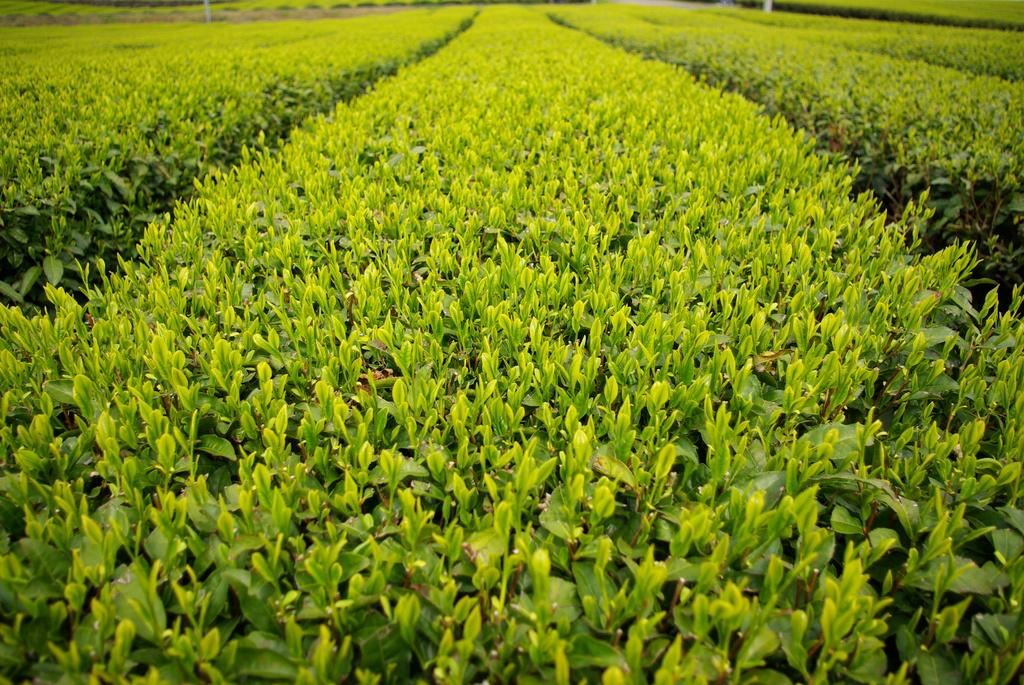What is the main setting of the image? There is a field in the image. What type of vegetation can be seen in the field? The field has green plants everywhere. Where is the desk located in the image? There is no desk present in the image; it is a field with green plants. How many apples can be seen on the ground in the image? There are no apples present in the image; it is a field with green plants. 